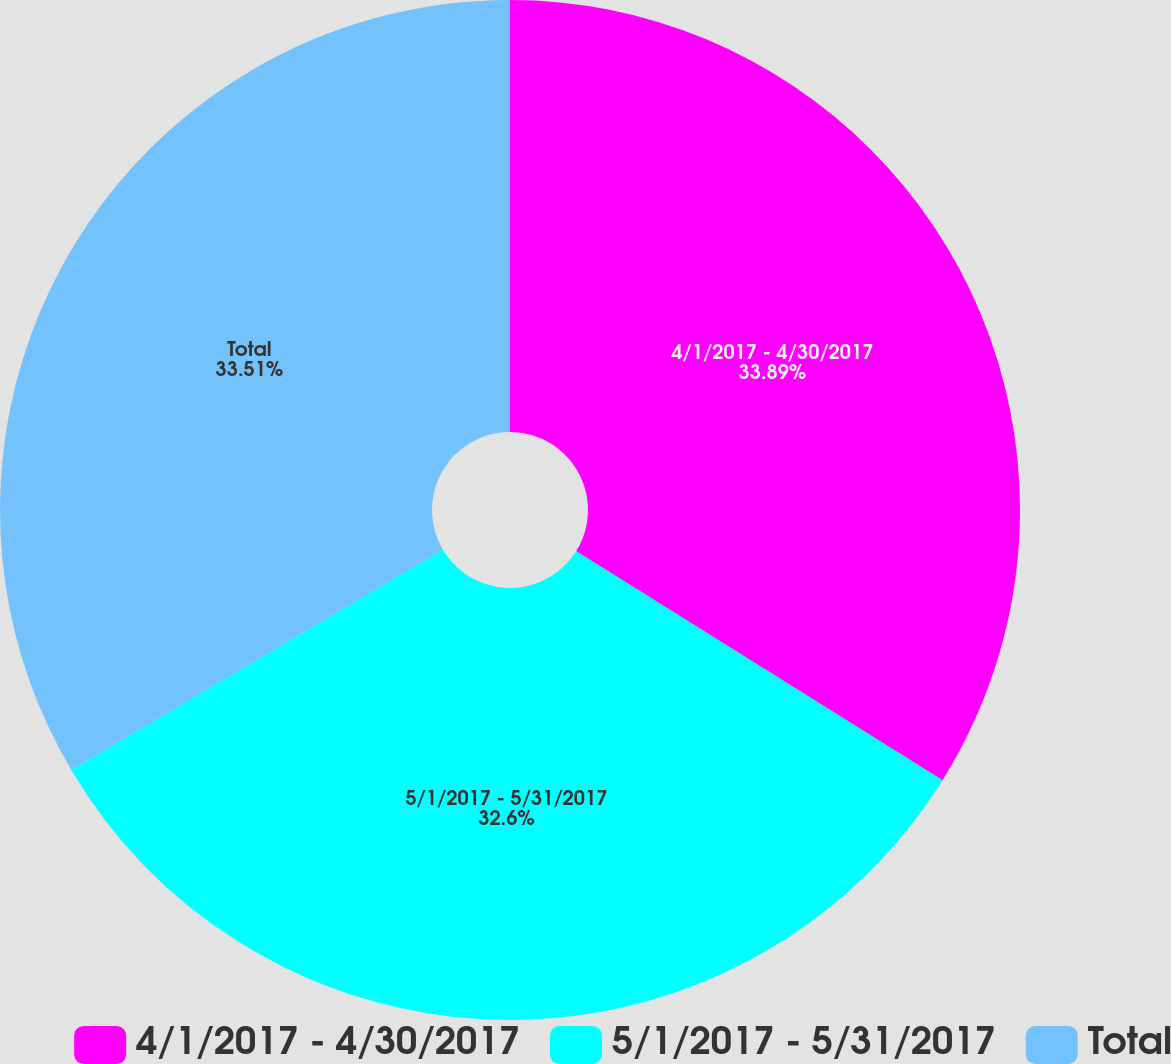Convert chart. <chart><loc_0><loc_0><loc_500><loc_500><pie_chart><fcel>4/1/2017 - 4/30/2017<fcel>5/1/2017 - 5/31/2017<fcel>Total<nl><fcel>33.89%<fcel>32.6%<fcel>33.51%<nl></chart> 